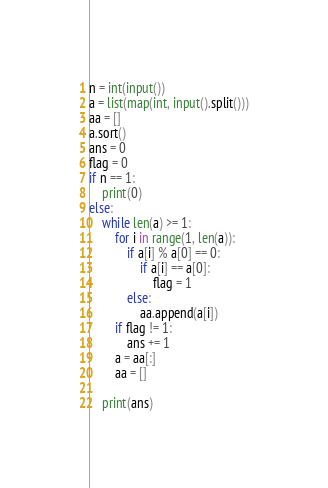<code> <loc_0><loc_0><loc_500><loc_500><_Python_>n = int(input())
a = list(map(int, input().split()))
aa = []
a.sort()
ans = 0
flag = 0
if n == 1:
    print(0)
else:
    while len(a) >= 1:
        for i in range(1, len(a)):
            if a[i] % a[0] == 0:
                if a[i] == a[0]:
                    flag = 1
            else:
                aa.append(a[i])
        if flag != 1:
            ans += 1
        a = aa[:]
        aa = []

    print(ans)</code> 